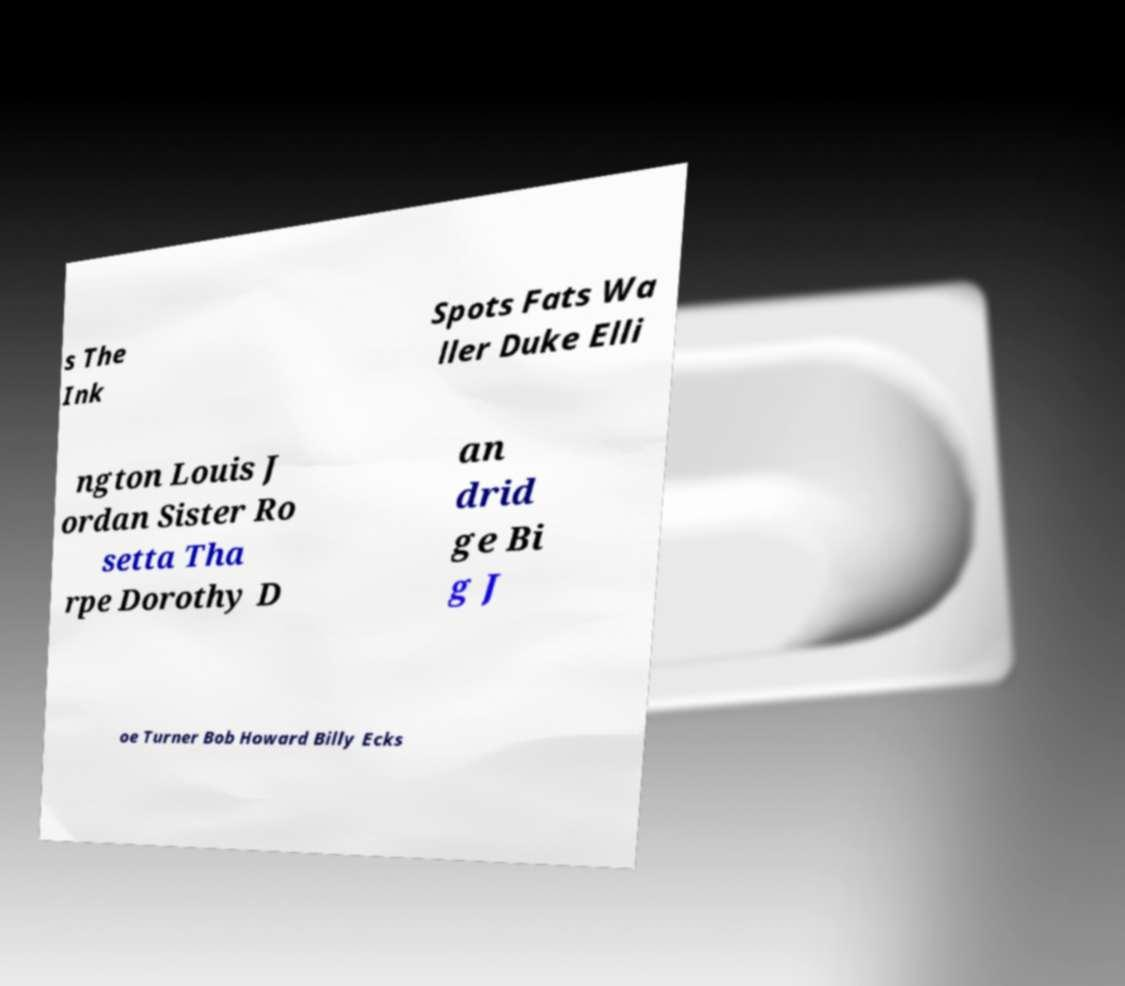Can you read and provide the text displayed in the image?This photo seems to have some interesting text. Can you extract and type it out for me? s The Ink Spots Fats Wa ller Duke Elli ngton Louis J ordan Sister Ro setta Tha rpe Dorothy D an drid ge Bi g J oe Turner Bob Howard Billy Ecks 